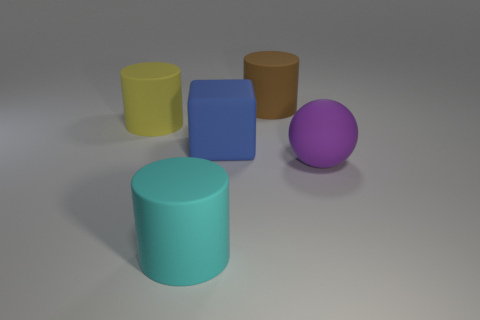Subtract all brown cylinders. How many cylinders are left? 2 Add 5 green spheres. How many objects exist? 10 Subtract all blocks. How many objects are left? 4 Subtract all blue rubber things. Subtract all cyan metallic balls. How many objects are left? 4 Add 2 blue matte blocks. How many blue matte blocks are left? 3 Add 2 yellow rubber objects. How many yellow rubber objects exist? 3 Subtract 0 brown blocks. How many objects are left? 5 